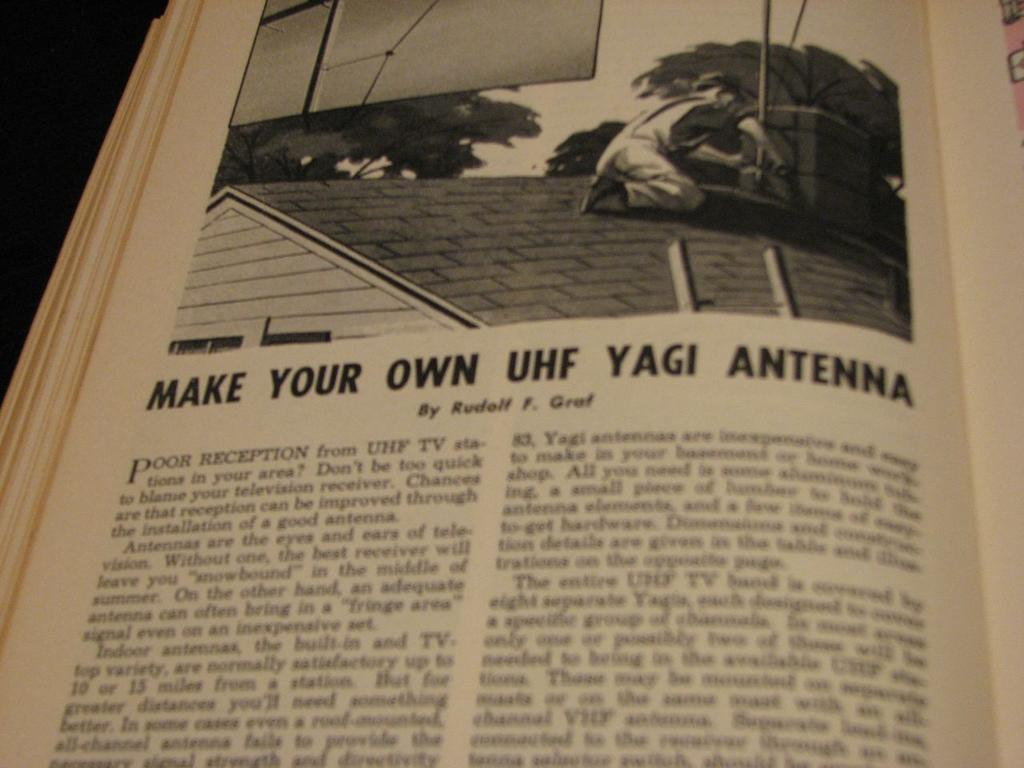<image>
Render a clear and concise summary of the photo. An article in a book teaches you ho to make your UHF yagi antena 